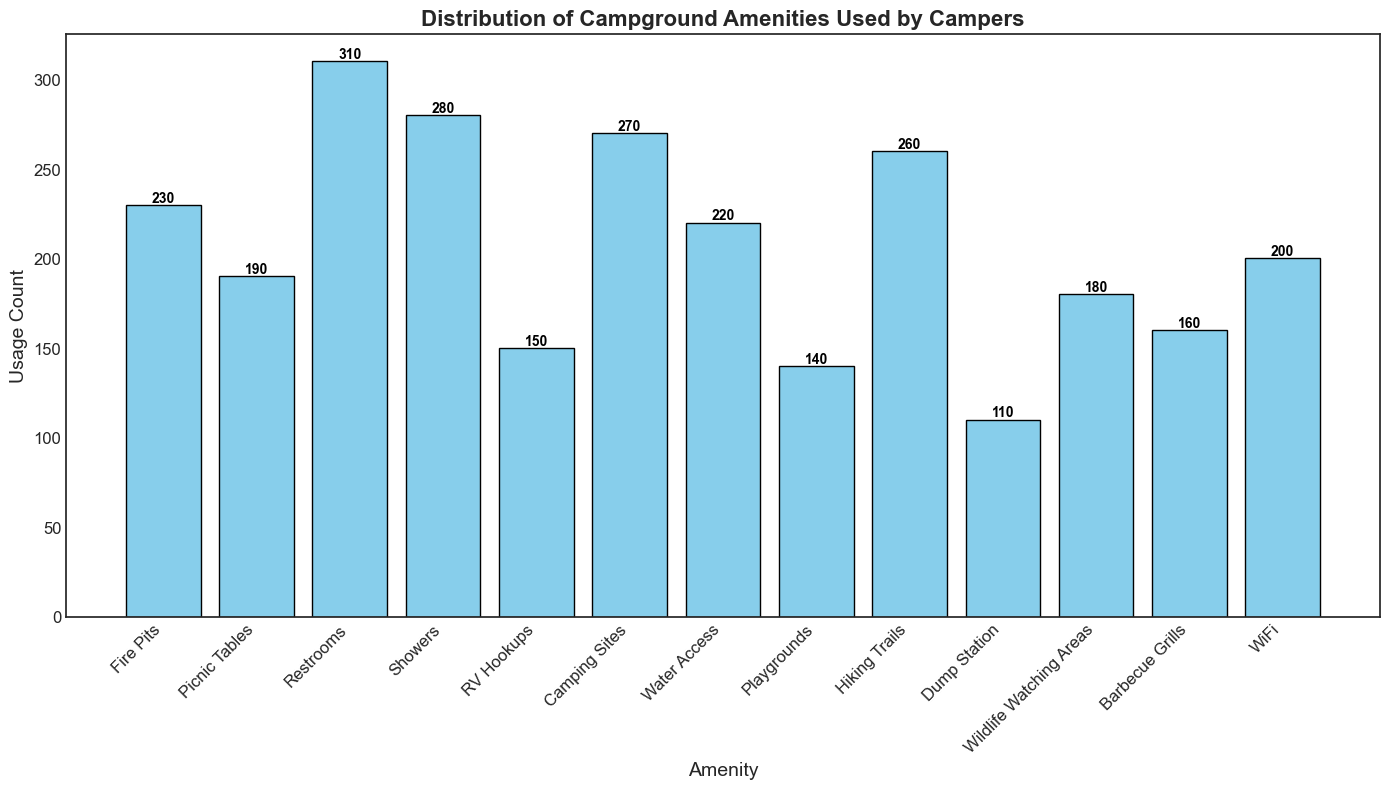How many campers used the top 3 most popular amenities combined? The top 3 most popular amenities are Restrooms, Showers, and Camping Sites. Add their usage counts: 310 (Restrooms) + 280 (Showers) + 270 (Camping Sites) = 860.
Answer: 860 Which amenity is used more, WiFi or Barbecue Grills? Compare the usage counts for WiFi and Barbecue Grills. WiFi has a usage count of 200, while Barbecue Grills have 160.
Answer: WiFi Are Fire Pits used more frequently than Water Access? Compare the usage counts for Fire Pits and Water Access. Fire Pits have a usage count of 230, while Water Access has 220.
Answer: Yes What is the difference between the usage count of Restrooms and Dump Station? Subtract the usage count of Dump Station from that of Restrooms. 310 (Restrooms) - 110 (Dump Station) = 200.
Answer: 200 Which amenities have usage counts less than 200? Identify the amenities with usage counts less than 200: RV Hookups (150), Playgrounds (140), Dump Station (110), Wildlife Watching Areas (180), and Barbecue Grills (160).
Answer: RV Hookups, Playgrounds, Dump Station, Wildlife Watching Areas, Barbecue Grills How many total campers used amenities related to cooking (Fire Pits, Barbecue Grills, Picnic Tables)? Add the usage counts of Fire Pits, Barbecue Grills, and Picnic Tables. 230 (Fire Pits) + 160 (Barbecue Grills) + 190 (Picnic Tables) = 580.
Answer: 580 Which amenity has the lowest usage count? Find the amenity with the smallest number, which is Dump Station with a usage count of 110.
Answer: Dump Station What is the average usage count of all amenities? Sum up all usage counts and divide by the number of amenities. Total sum is 230 + 190 + 310 + 280 + 150 + 270 + 220 + 140 + 260 + 110 + 180 + 160 + 200 = 2700. There are 13 amenities. The average is 2700 / 13 ≈ 207.7.
Answer: 207.7 Is the usage count for Hiking Trails higher than the average usage count of all amenities? The average usage count of all amenities is 207.7, and the usage count for Hiking Trails is 260. Since 260 > 207.7, Hiking Trails has a higher count than the average.
Answer: Yes 